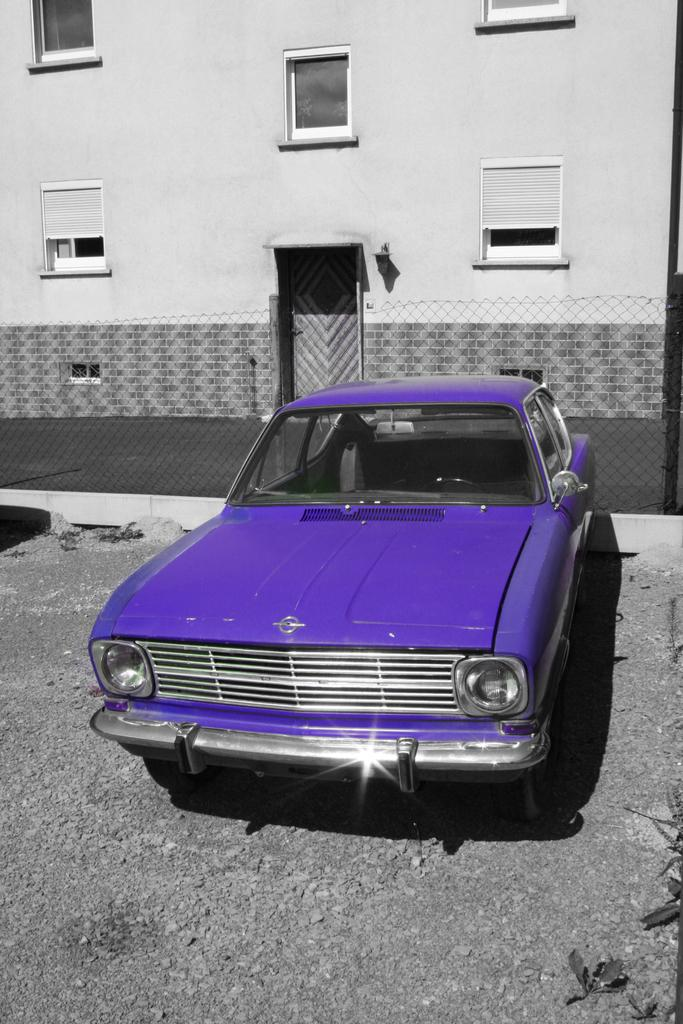What can be observed about the image's appearance? The image is edited. What is located on the ground in the image? There is a car placed on the ground. What type of barrier is present behind the car? There is a metal fence on the backside of the car. What can be seen in the distance behind the car and fence? There is a building with windows in the background. What type of finger can be seen holding the vessel in the image? There is no finger or vessel present in the image. What type of education is being provided in the image? There is no indication of education or any educational activity in the image. 